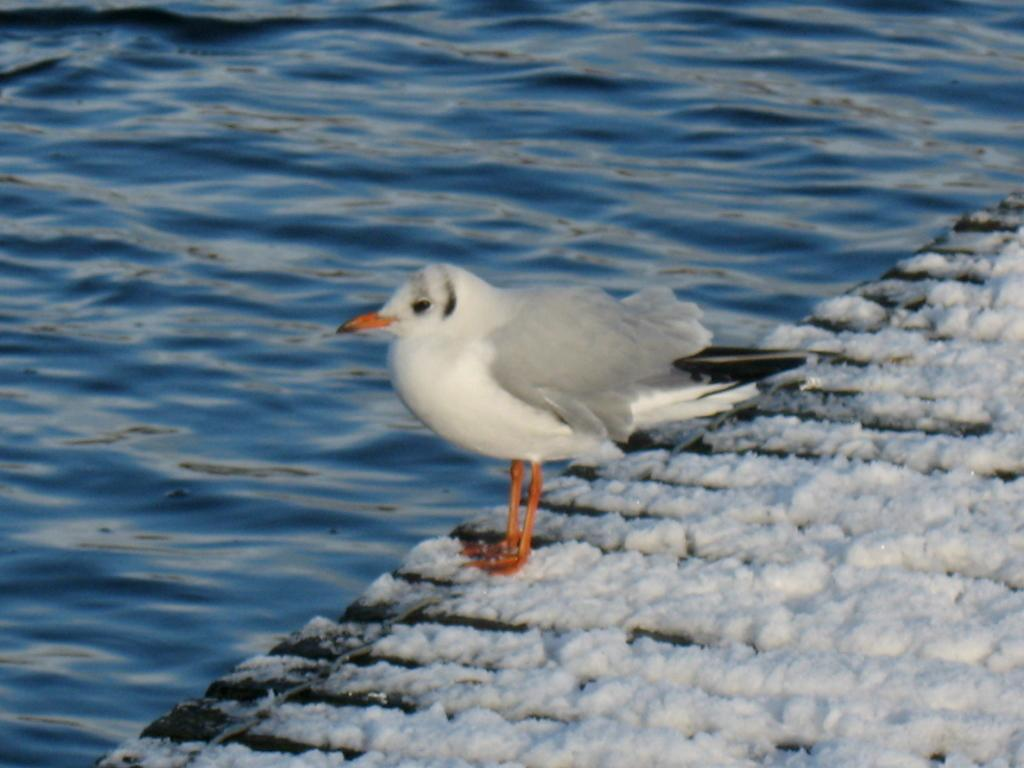What type of animal can be seen in the image? There is a bird in the image. Where is the bird located? The bird is on the surface of something. What can be seen in the background of the image? There is water visible in the background of the image. What type of potato is being used as a face mask in the image? There is no potato or face mask present in the image; it features a bird on the surface of something with water visible in the background. 